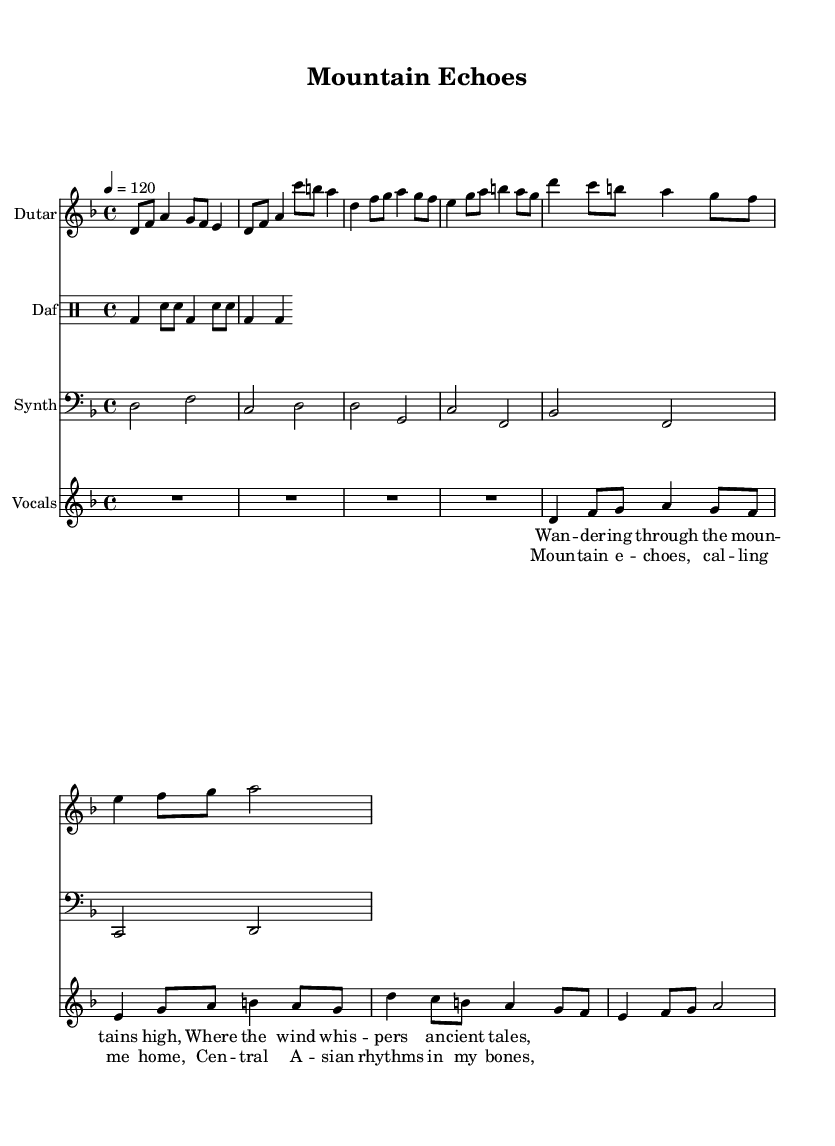What is the key signature of this music? The key signature is D minor, which has one flat (B flat). This is determined by identifying the key shown at the beginning of the score, indicated by "d" in the global music section of the code.
Answer: D minor What is the time signature of this music? The time signature is 4/4, meaning there are four beats in each measure, and the quarter note gets one beat. This can be found at the beginning of the score, denoted as "\time 4/4".
Answer: 4/4 What is the tempo marking indicated in the music? The tempo marking is quarter note equals 120 beats per minute. This is provided in the global section of the code where it states "\tempo 4 = 120".
Answer: 120 How many measures are in the chorus section? The chorus section contains four measures. This can be verified by counting the number of distinct rhythmic groupings represented under the chorus lyrics. Each line represents a measure, and there are four such lines for the chorus.
Answer: 4 What traditional Central Asian instrument is featured in this music? The instrument featured in this music is the dutar, which is mentioned in the staff for the dutar and is a well-known traditional instrument from Central Asia.
Answer: Dutар What is the main theme expressed in the lyrics? The main theme expressed in the lyrics revolves around nature and a connection to the mountains, with references to wandering and ancient tales found in the verse section. This theme is apparent in the lyrics presented above the vocal staff.
Answer: Nature 